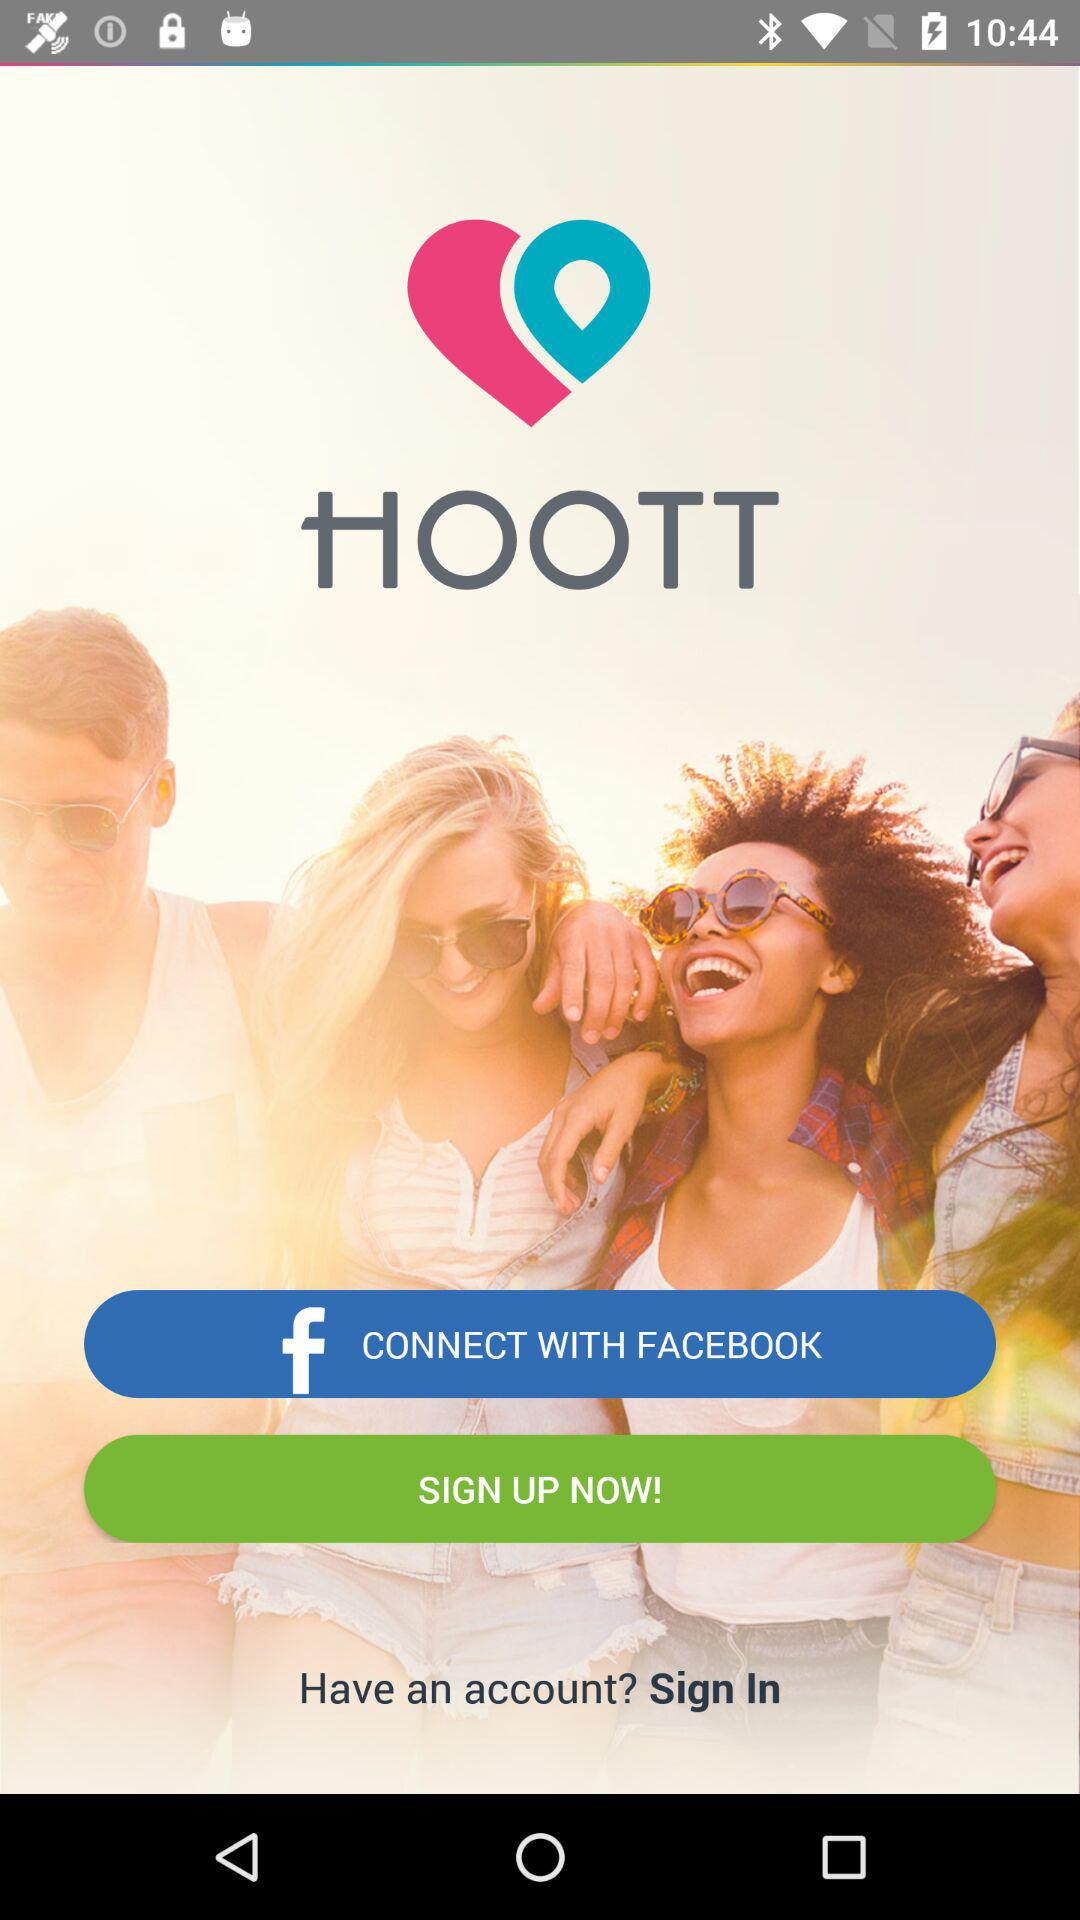What social media option is given for the sign-up? The given option for the sign-up is "FACEBOOK". 